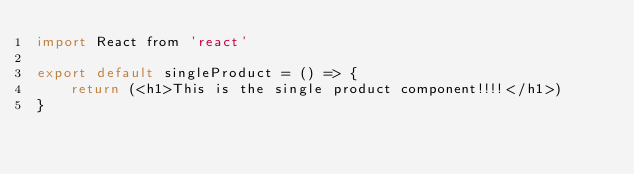<code> <loc_0><loc_0><loc_500><loc_500><_JavaScript_>import React from 'react'

export default singleProduct = () => {
    return (<h1>This is the single product component!!!!</h1>)
}</code> 